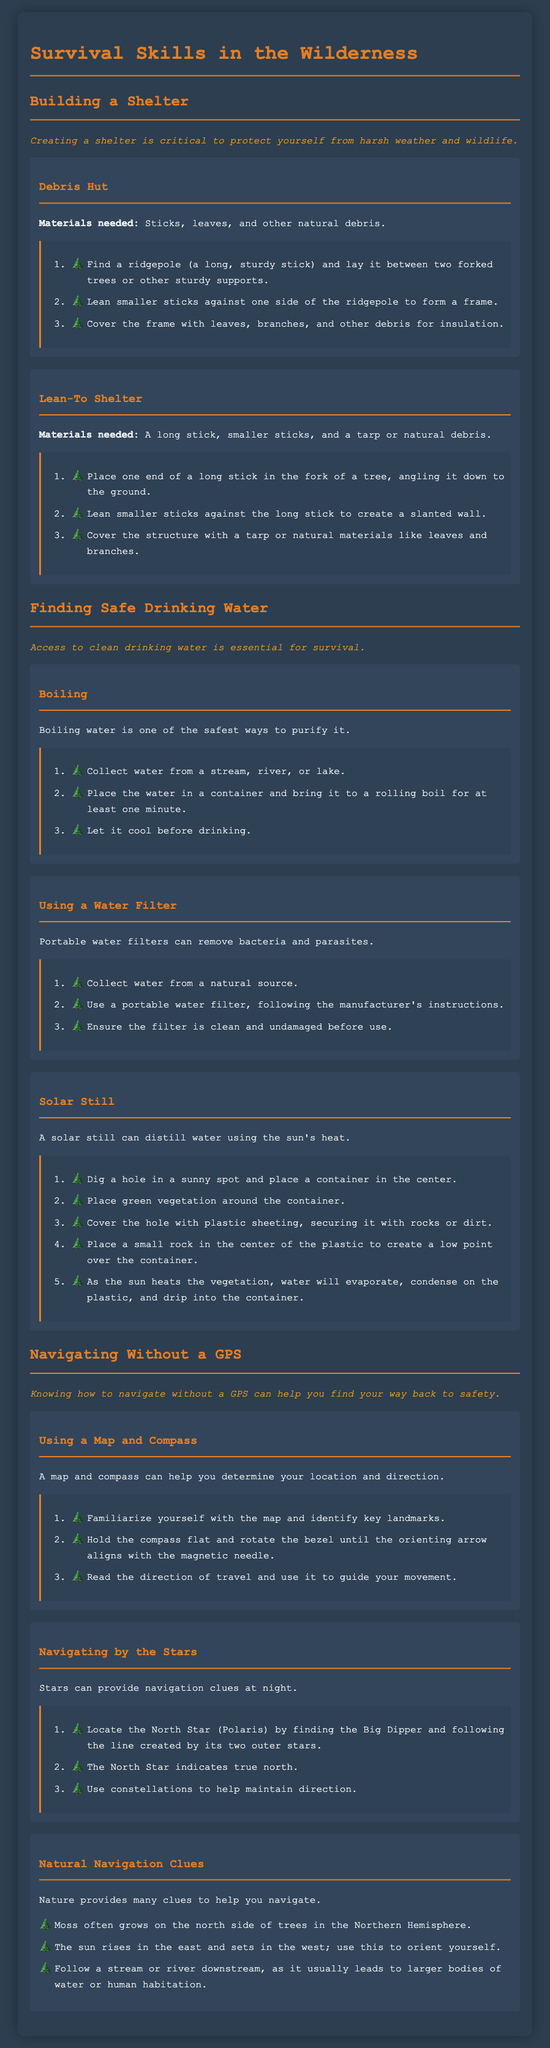What is the importance of creating a shelter? The importance is highlighted in the document, stating that it is critical to protect yourself from harsh weather and wildlife.
Answer: Critical to protect yourself from harsh weather and wildlife What materials are needed for a Debris Hut? The document lists sticks, leaves, and other natural debris as required materials for building a Debris Hut.
Answer: Sticks, leaves, and other natural debris How long should water be boiled to purify it? The document specifies boiling water for at least one minute to ensure it is safe to drink.
Answer: One minute What is the first step in making a Solar Still? The document advises digging a hole in a sunny spot and placing a container in the center as the first step.
Answer: Dig a hole in a sunny spot and place a container in the center Which compass feature must align with the magnetic needle? The document indicates that the orienting arrow of the compass must align with the magnetic needle.
Answer: The orienting arrow How can you locate the North Star? The document explains that you can find the North Star by locating the Big Dipper and following the line created by its two outer stars.
Answer: By finding the Big Dipper What natural clues can help with navigation? The document lists several, including moss growing on the north side of trees, sun position, and following a stream downstream.
Answer: Moss, sun position, following a stream What should you ensure before using a portable water filter? According to the document, you should ensure the filter is clean and undamaged before use.
Answer: Clean and undamaged Which type of shelter requires a tarp or natural debris? The document states that the Lean-To Shelter requires a tarp or natural debris as materials.
Answer: Lean-To Shelter 